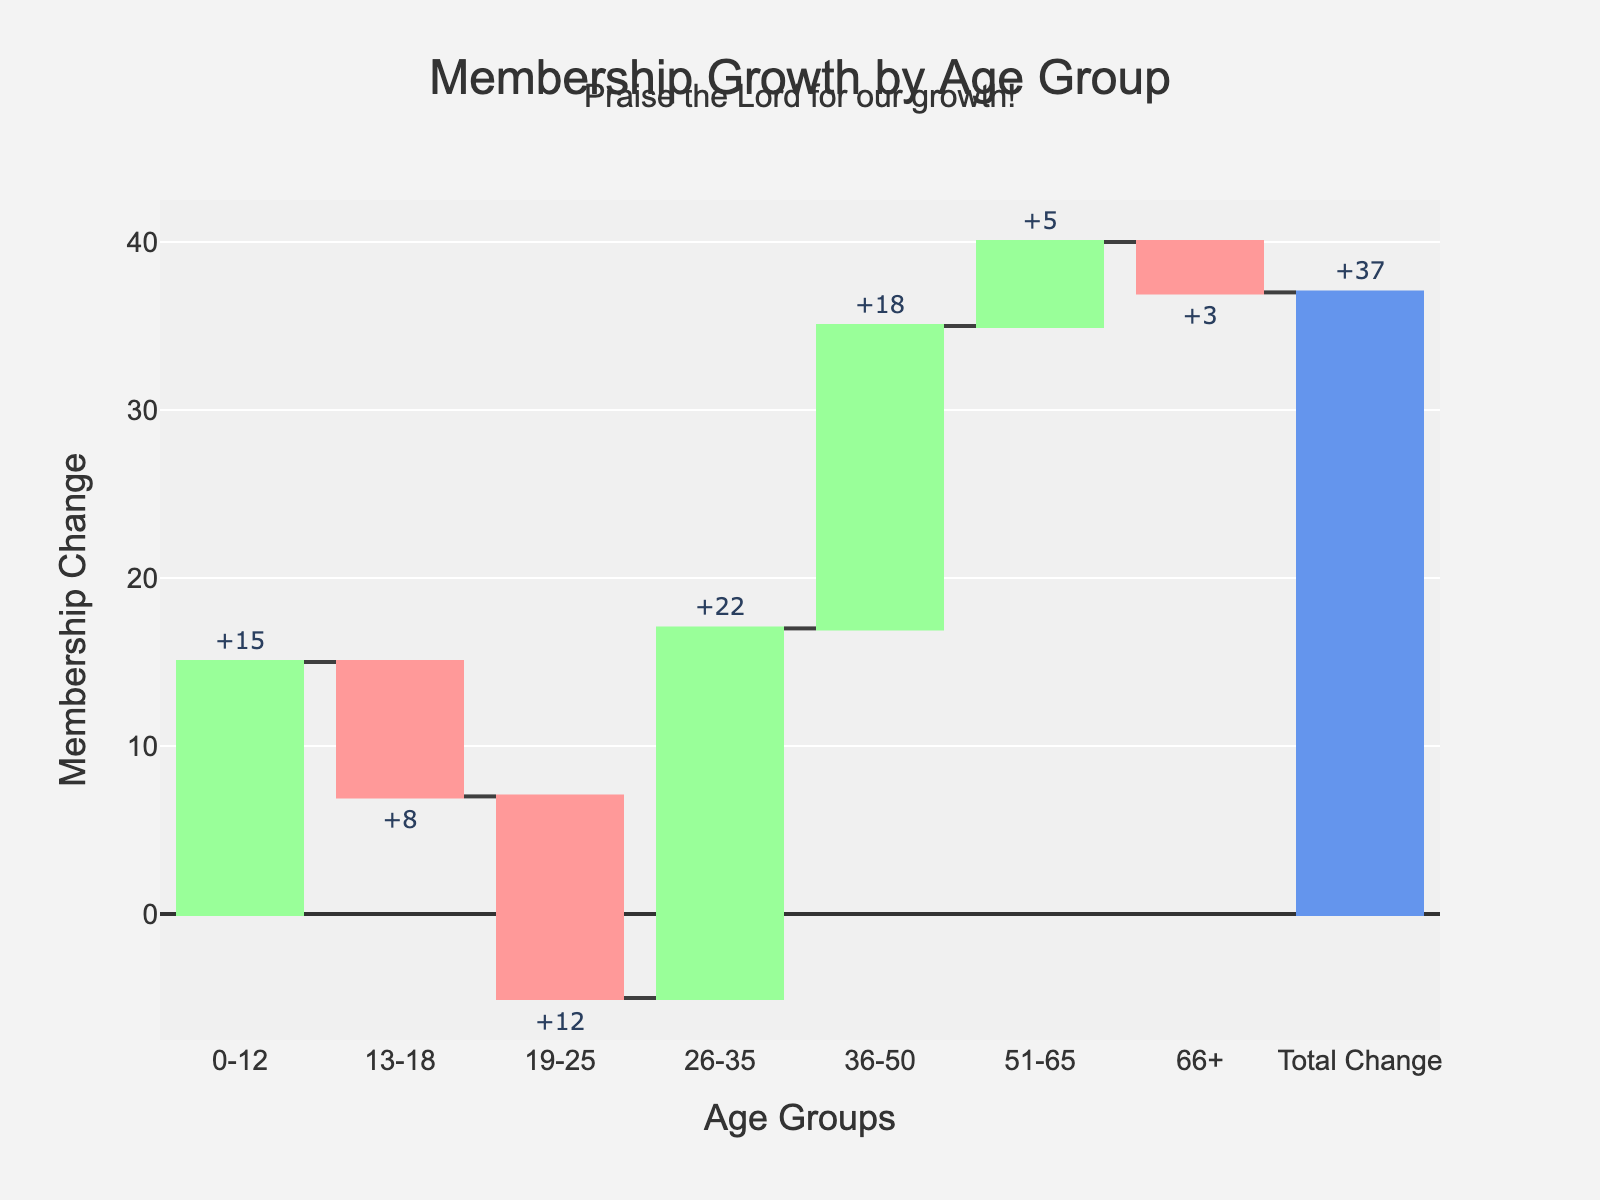How many age groups had a positive change in membership? The total number of age groups shown on the x-axis is 7. By looking at the bars indicating positive change (green-colored), we can see that 0-12, 26-35, 36-50, and 51-65 had a positive change. Therefore, 4 age groups experienced positive growth.
Answer: 4 Which age group experienced the highest increase in membership? By observing the heights of the green-colored bars representing positive changes, the 26-35 age group has the highest increase in membership, as it visually has the tallest bar among the positive changes.
Answer: 26-35 Which age group experienced the largest decrease in membership? Looking at the red-colored bars indicating a decrease in membership, the 19-25 age group has the largest negative change, having the longest downward bar among the negative changes.
Answer: 19-25 What is the total change in membership over the past five years? The total change in membership is the last bar on the right, which is specifically indicated to show the summary of all previous changes. This bar is colored differently (blue) and labeled 'Total Change'. The value shown next to it is 37.
Answer: 37 How does the membership change for the 0-12 age group compare to the 13-18 age group? By examining the heights of the bars labeled 0-12 and 13-18, the 0-12 age group has a positive change (+15), whereas the 13-18 age group has a negative change (-8). Comparing these two, the 0-12 age group shows an increase while the 13-18 age group shows a decrease in membership.
Answer: 0-12 increased, 13-18 decreased Which age group had the smallest change in membership? The 66+ age group has the smallest change in membership, indicated by a short red-colored bar representing -3, which is smaller in magnitude compared to the absolute values of other bars.
Answer: 66+ What is the combined membership change of both positive and negative changes excluding 0-12 and 66+ age groups? Add the positive and negative changes for the age groups 13-18, 19-25, 26-35, 36-50, and 51-65. The changes are -8, -12, +22, +18, and +5 respectively. Summing these gives (-8) + (-12) + 22 + 18 + 5 = 25.
Answer: 25 By how much did the membership change in the 36-50 age group differ from the 51-65 age group? The 36-50 age group experienced an increase of 18, while the 51-65 age group experienced an increase of 5. The difference between these changes is 18 - 5 = 13.
Answer: 13 In the figure, how many total groups have bars above zero on the y-axis, including total change? Count all the bars that extend above the zero line on the y-axis. Four age groups (0-12, 26-35, 36-50, 51-65) and the Total Change bar extend above zero, resulting in 5 groups in total.
Answer: 5 